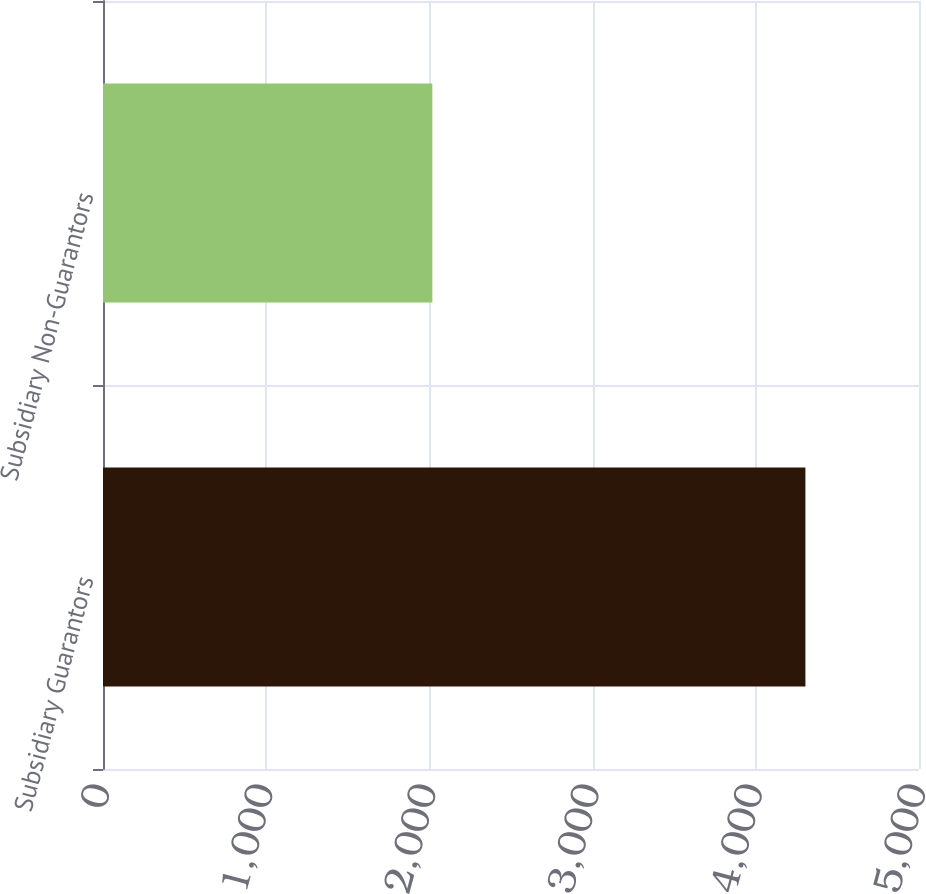Convert chart. <chart><loc_0><loc_0><loc_500><loc_500><bar_chart><fcel>Subsidiary Guarantors<fcel>Subsidiary Non-Guarantors<nl><fcel>4304<fcel>2018<nl></chart> 